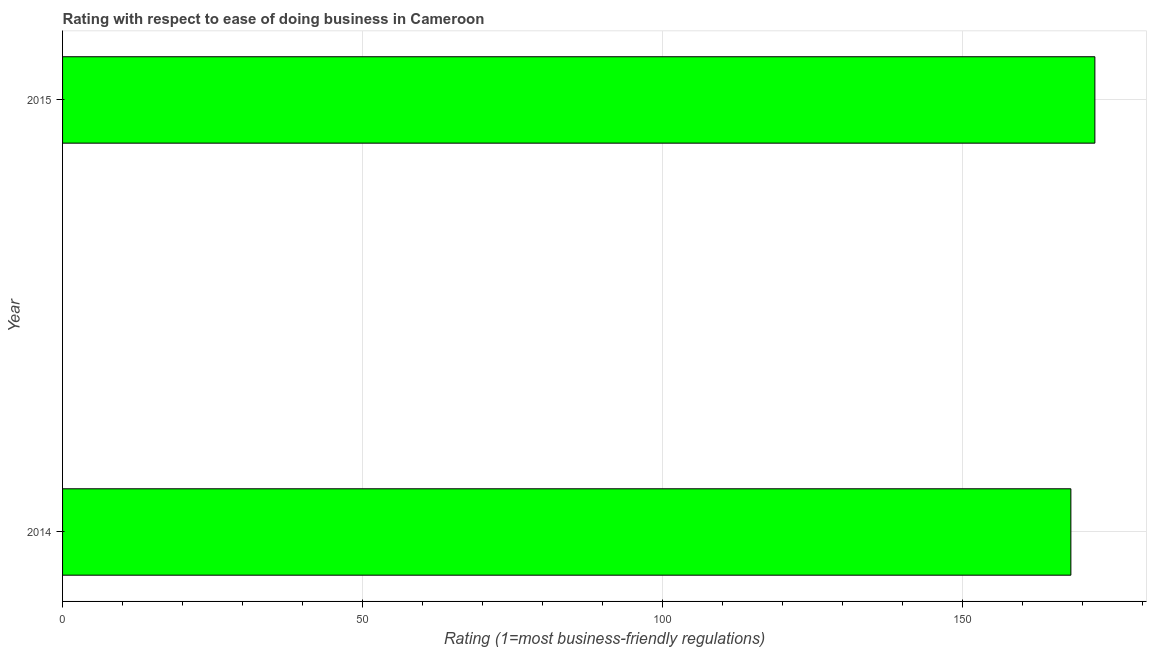Does the graph contain grids?
Ensure brevity in your answer.  Yes. What is the title of the graph?
Offer a very short reply. Rating with respect to ease of doing business in Cameroon. What is the label or title of the X-axis?
Your answer should be compact. Rating (1=most business-friendly regulations). What is the label or title of the Y-axis?
Make the answer very short. Year. What is the ease of doing business index in 2014?
Keep it short and to the point. 168. Across all years, what is the maximum ease of doing business index?
Offer a very short reply. 172. Across all years, what is the minimum ease of doing business index?
Give a very brief answer. 168. In which year was the ease of doing business index maximum?
Offer a terse response. 2015. What is the sum of the ease of doing business index?
Offer a terse response. 340. What is the average ease of doing business index per year?
Make the answer very short. 170. What is the median ease of doing business index?
Offer a very short reply. 170. In how many years, is the ease of doing business index greater than 150 ?
Give a very brief answer. 2. Do a majority of the years between 2015 and 2014 (inclusive) have ease of doing business index greater than 100 ?
Offer a very short reply. No. Is the ease of doing business index in 2014 less than that in 2015?
Your response must be concise. Yes. In how many years, is the ease of doing business index greater than the average ease of doing business index taken over all years?
Your response must be concise. 1. How many years are there in the graph?
Make the answer very short. 2. Are the values on the major ticks of X-axis written in scientific E-notation?
Keep it short and to the point. No. What is the Rating (1=most business-friendly regulations) of 2014?
Your answer should be very brief. 168. What is the Rating (1=most business-friendly regulations) of 2015?
Keep it short and to the point. 172. 